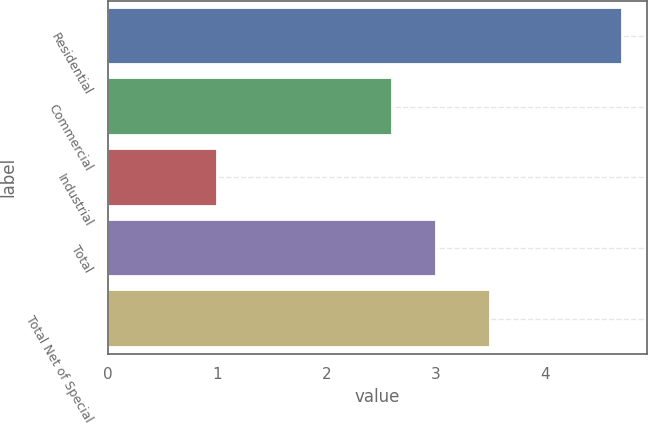Convert chart. <chart><loc_0><loc_0><loc_500><loc_500><bar_chart><fcel>Residential<fcel>Commercial<fcel>Industrial<fcel>Total<fcel>Total Net of Special<nl><fcel>4.7<fcel>2.6<fcel>1<fcel>3<fcel>3.5<nl></chart> 